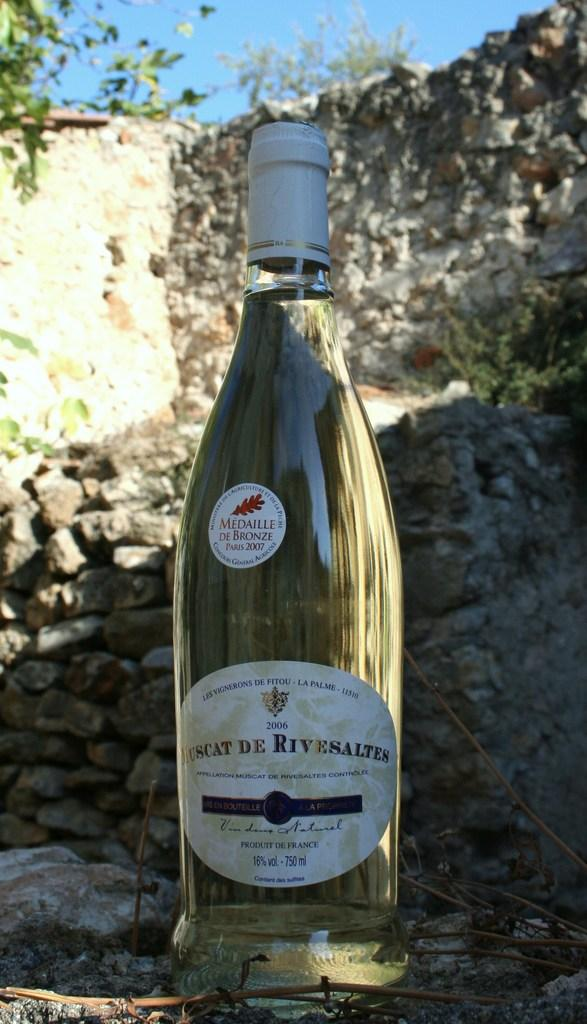<image>
Present a compact description of the photo's key features. A bottle of Muscat De Rivesaltes sits on the ground near a bunch of rocks. 